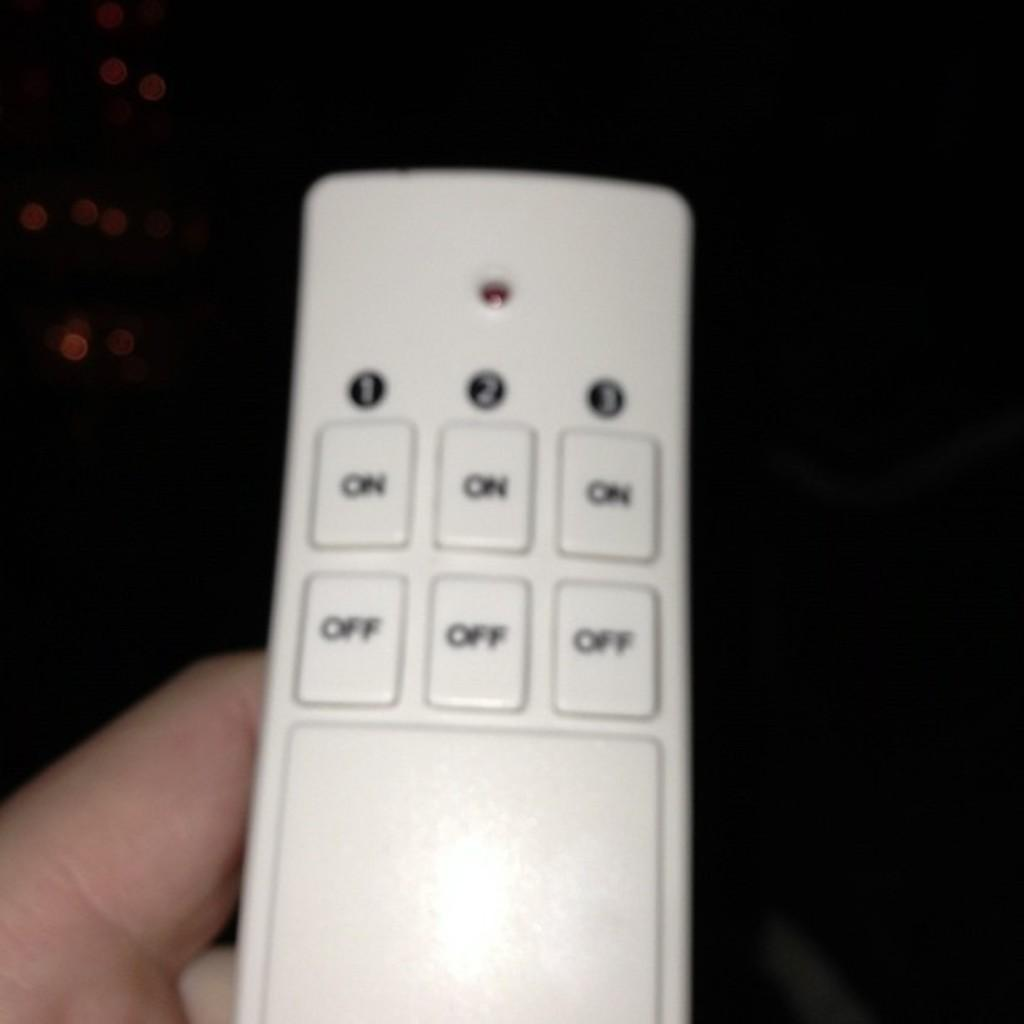<image>
Offer a succinct explanation of the picture presented. A person is holding a white controller that has buttons for on and off. 